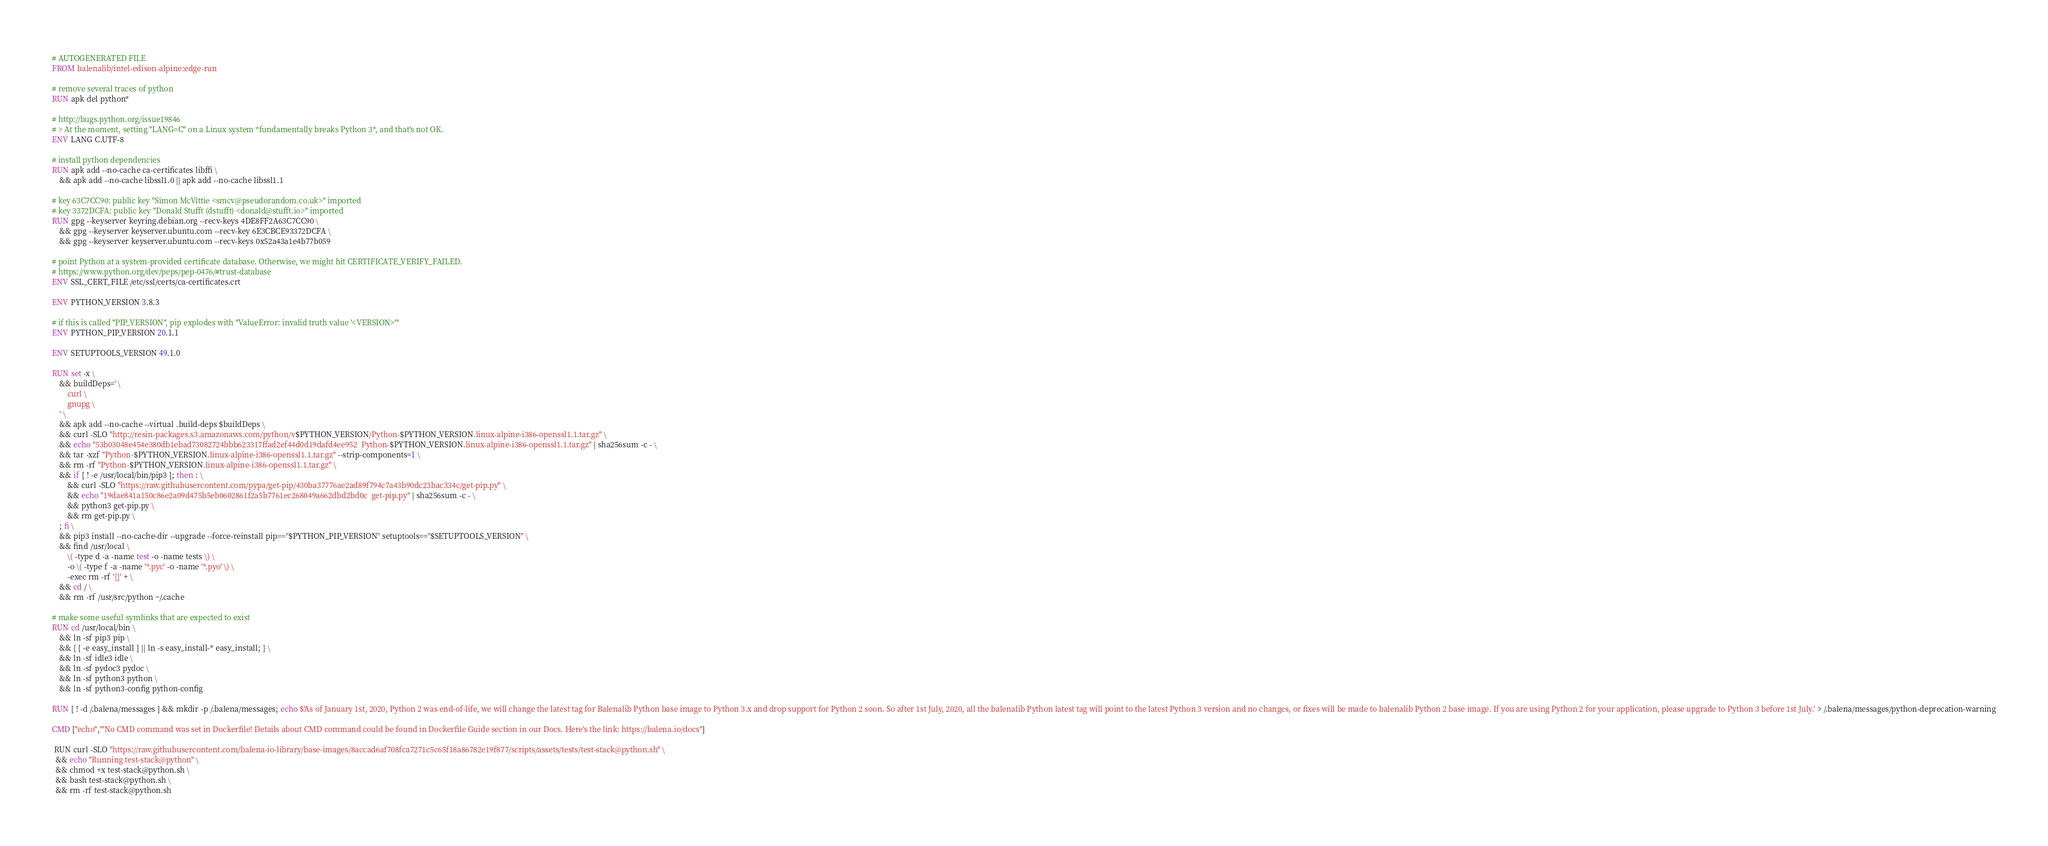<code> <loc_0><loc_0><loc_500><loc_500><_Dockerfile_># AUTOGENERATED FILE
FROM balenalib/intel-edison-alpine:edge-run

# remove several traces of python
RUN apk del python*

# http://bugs.python.org/issue19846
# > At the moment, setting "LANG=C" on a Linux system *fundamentally breaks Python 3*, and that's not OK.
ENV LANG C.UTF-8

# install python dependencies
RUN apk add --no-cache ca-certificates libffi \
	&& apk add --no-cache libssl1.0 || apk add --no-cache libssl1.1

# key 63C7CC90: public key "Simon McVittie <smcv@pseudorandom.co.uk>" imported
# key 3372DCFA: public key "Donald Stufft (dstufft) <donald@stufft.io>" imported
RUN gpg --keyserver keyring.debian.org --recv-keys 4DE8FF2A63C7CC90 \
	&& gpg --keyserver keyserver.ubuntu.com --recv-key 6E3CBCE93372DCFA \
	&& gpg --keyserver keyserver.ubuntu.com --recv-keys 0x52a43a1e4b77b059

# point Python at a system-provided certificate database. Otherwise, we might hit CERTIFICATE_VERIFY_FAILED.
# https://www.python.org/dev/peps/pep-0476/#trust-database
ENV SSL_CERT_FILE /etc/ssl/certs/ca-certificates.crt

ENV PYTHON_VERSION 3.8.3

# if this is called "PIP_VERSION", pip explodes with "ValueError: invalid truth value '<VERSION>'"
ENV PYTHON_PIP_VERSION 20.1.1

ENV SETUPTOOLS_VERSION 49.1.0

RUN set -x \
	&& buildDeps=' \
		curl \
		gnupg \
	' \
	&& apk add --no-cache --virtual .build-deps $buildDeps \
	&& curl -SLO "http://resin-packages.s3.amazonaws.com/python/v$PYTHON_VERSION/Python-$PYTHON_VERSION.linux-alpine-i386-openssl1.1.tar.gz" \
	&& echo "53b03048e454e380db1ebad73082724bbb623317ffad2ef44d0d19dafd4ee952  Python-$PYTHON_VERSION.linux-alpine-i386-openssl1.1.tar.gz" | sha256sum -c - \
	&& tar -xzf "Python-$PYTHON_VERSION.linux-alpine-i386-openssl1.1.tar.gz" --strip-components=1 \
	&& rm -rf "Python-$PYTHON_VERSION.linux-alpine-i386-openssl1.1.tar.gz" \
	&& if [ ! -e /usr/local/bin/pip3 ]; then : \
		&& curl -SLO "https://raw.githubusercontent.com/pypa/get-pip/430ba37776ae2ad89f794c7a43b90dc23bac334c/get-pip.py" \
		&& echo "19dae841a150c86e2a09d475b5eb0602861f2a5b7761ec268049a662dbd2bd0c  get-pip.py" | sha256sum -c - \
		&& python3 get-pip.py \
		&& rm get-pip.py \
	; fi \
	&& pip3 install --no-cache-dir --upgrade --force-reinstall pip=="$PYTHON_PIP_VERSION" setuptools=="$SETUPTOOLS_VERSION" \
	&& find /usr/local \
		\( -type d -a -name test -o -name tests \) \
		-o \( -type f -a -name '*.pyc' -o -name '*.pyo' \) \
		-exec rm -rf '{}' + \
	&& cd / \
	&& rm -rf /usr/src/python ~/.cache

# make some useful symlinks that are expected to exist
RUN cd /usr/local/bin \
	&& ln -sf pip3 pip \
	&& { [ -e easy_install ] || ln -s easy_install-* easy_install; } \
	&& ln -sf idle3 idle \
	&& ln -sf pydoc3 pydoc \
	&& ln -sf python3 python \
	&& ln -sf python3-config python-config

RUN [ ! -d /.balena/messages ] && mkdir -p /.balena/messages; echo $'As of January 1st, 2020, Python 2 was end-of-life, we will change the latest tag for Balenalib Python base image to Python 3.x and drop support for Python 2 soon. So after 1st July, 2020, all the balenalib Python latest tag will point to the latest Python 3 version and no changes, or fixes will be made to balenalib Python 2 base image. If you are using Python 2 for your application, please upgrade to Python 3 before 1st July.' > /.balena/messages/python-deprecation-warning

CMD ["echo","'No CMD command was set in Dockerfile! Details about CMD command could be found in Dockerfile Guide section in our Docs. Here's the link: https://balena.io/docs"]

 RUN curl -SLO "https://raw.githubusercontent.com/balena-io-library/base-images/8accad6af708fca7271c5c65f18a86782e19f877/scripts/assets/tests/test-stack@python.sh" \
  && echo "Running test-stack@python" \
  && chmod +x test-stack@python.sh \
  && bash test-stack@python.sh \
  && rm -rf test-stack@python.sh 
</code> 